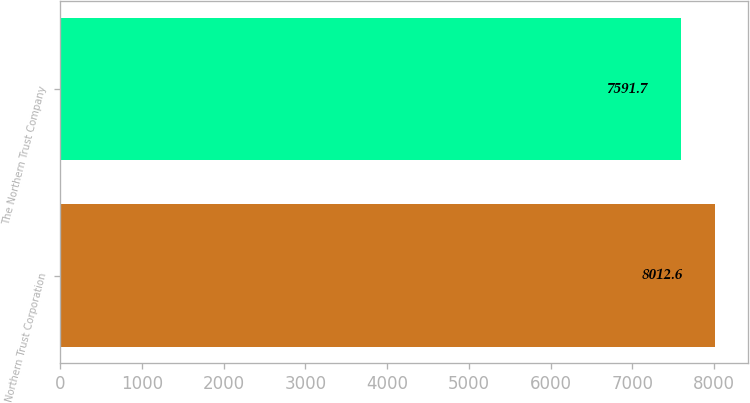Convert chart. <chart><loc_0><loc_0><loc_500><loc_500><bar_chart><fcel>Northern Trust Corporation<fcel>The Northern Trust Company<nl><fcel>8012.6<fcel>7591.7<nl></chart> 